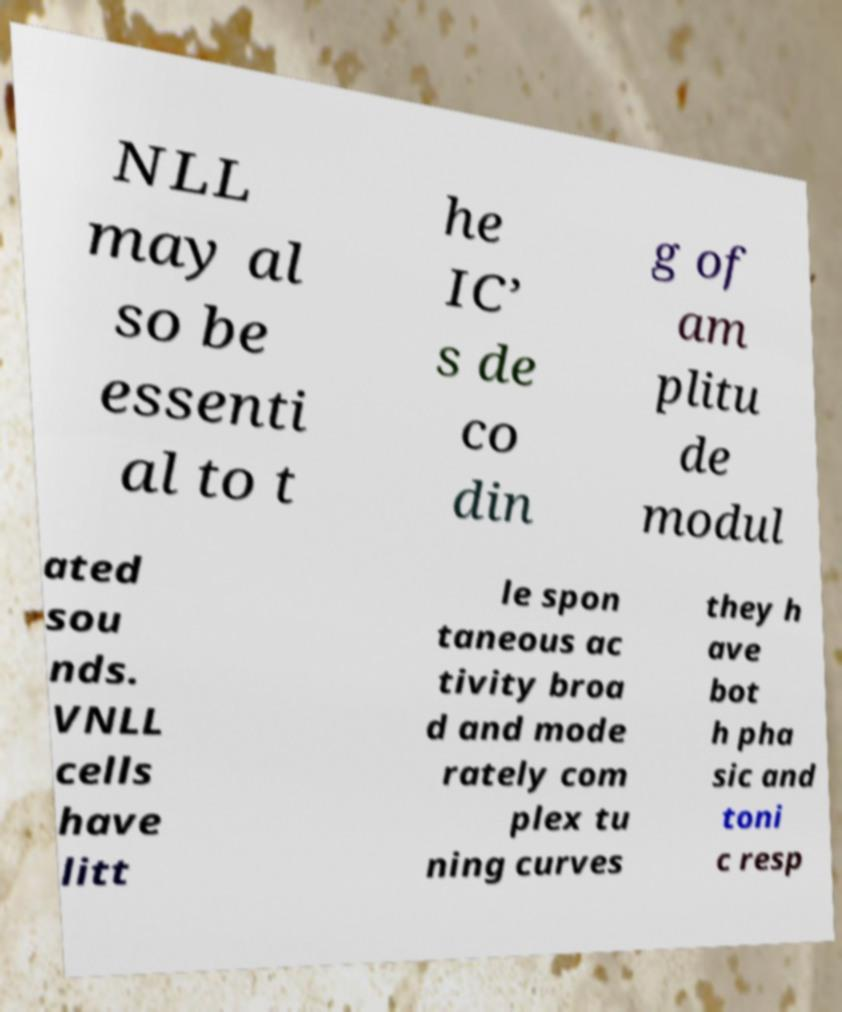There's text embedded in this image that I need extracted. Can you transcribe it verbatim? NLL may al so be essenti al to t he IC’ s de co din g of am plitu de modul ated sou nds. VNLL cells have litt le spon taneous ac tivity broa d and mode rately com plex tu ning curves they h ave bot h pha sic and toni c resp 